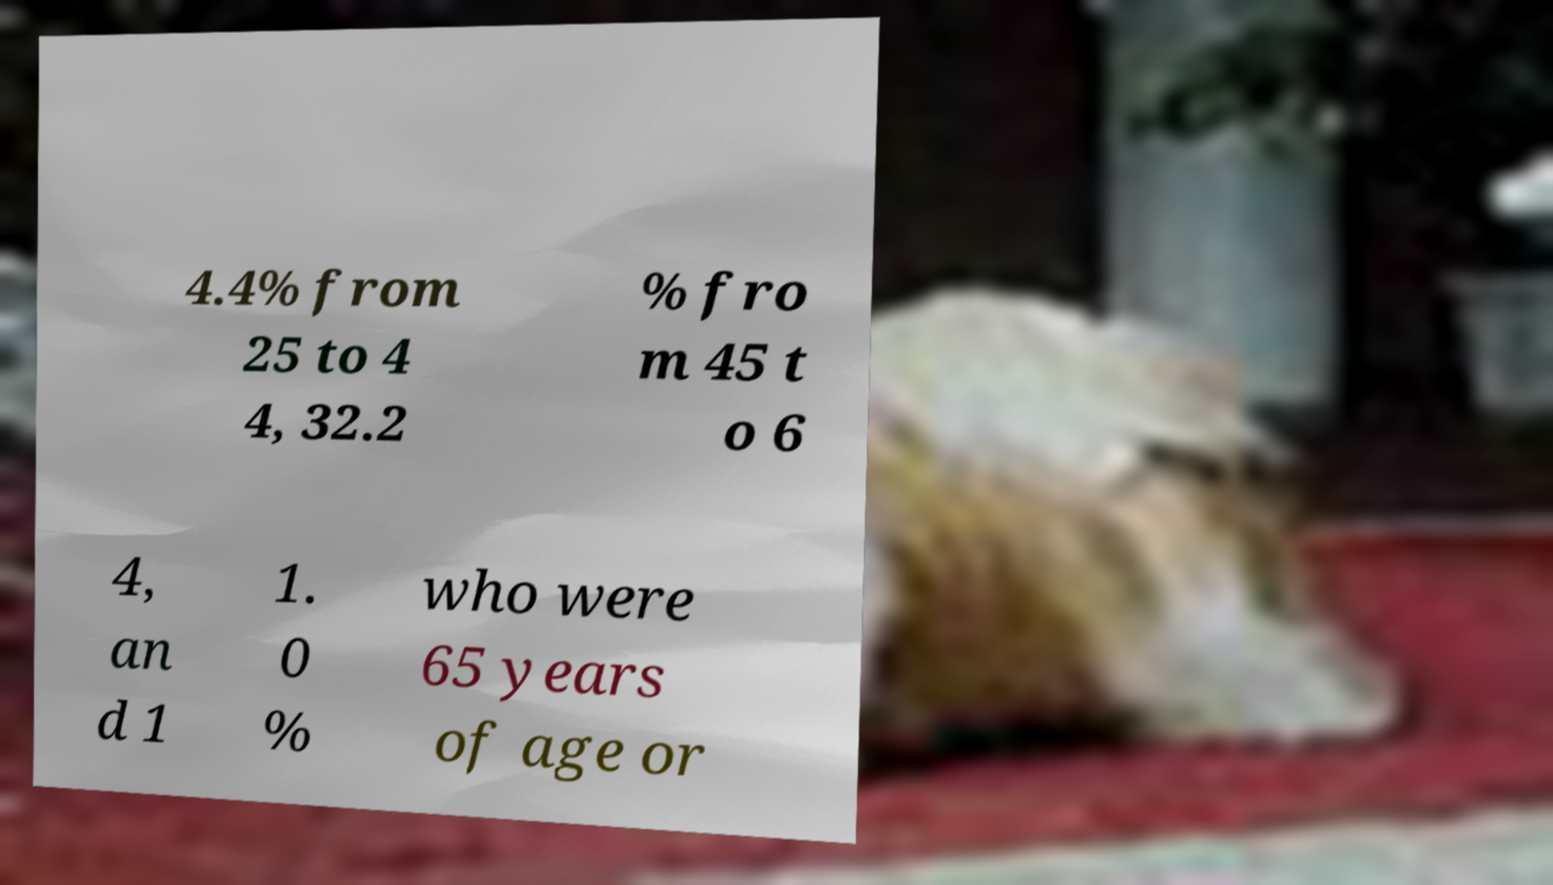Can you read and provide the text displayed in the image?This photo seems to have some interesting text. Can you extract and type it out for me? 4.4% from 25 to 4 4, 32.2 % fro m 45 t o 6 4, an d 1 1. 0 % who were 65 years of age or 